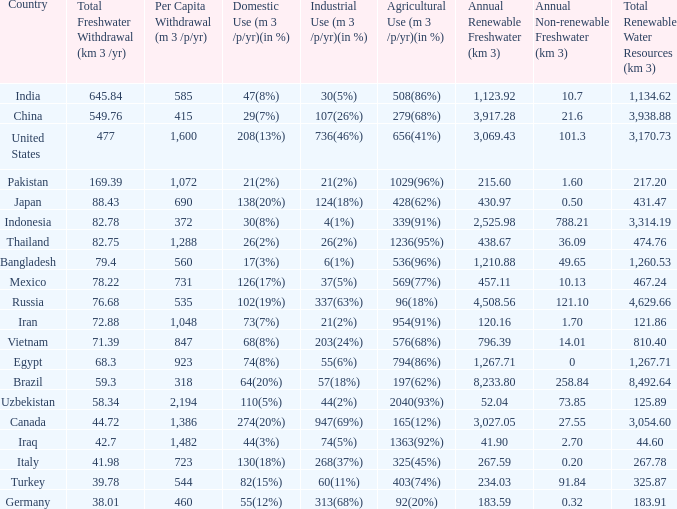Would you be able to parse every entry in this table? {'header': ['Country', 'Total Freshwater Withdrawal (km 3 /yr)', 'Per Capita Withdrawal (m 3 /p/yr)', 'Domestic Use (m 3 /p/yr)(in %)', 'Industrial Use (m 3 /p/yr)(in %)', 'Agricultural Use (m 3 /p/yr)(in %)', 'Annual Renewable Freshwater (km 3)', 'Annual Non-renewable Freshwater (km 3)', 'Total Renewable Water Resources (km 3)'], 'rows': [['India', '645.84', '585', '47(8%)', '30(5%)', '508(86%)', '1,123.92', '10.7', '1,134.62'], ['China', '549.76', '415', '29(7%)', '107(26%)', '279(68%)', '3,917.28', '21.6', '3,938.88'], ['United States', '477', '1,600', '208(13%)', '736(46%)', '656(41%)', '3,069.43', '101.3', '3,170.73'], ['Pakistan', '169.39', '1,072', '21(2%)', '21(2%)', '1029(96%)', '215.60', '1.60', '217.20'], ['Japan', '88.43', '690', '138(20%)', '124(18%)', '428(62%)', '430.97', '0.50', '431.47'], ['Indonesia', '82.78', '372', '30(8%)', '4(1%)', '339(91%)', '2,525.98', '788.21', '3,314.19'], ['Thailand', '82.75', '1,288', '26(2%)', '26(2%)', '1236(95%)', '438.67', '36.09', '474.76'], ['Bangladesh', '79.4', '560', '17(3%)', '6(1%)', '536(96%)', '1,210.88', '49.65', '1,260.53'], ['Mexico', '78.22', '731', '126(17%)', '37(5%)', '569(77%)', '457.11', '10.13', '467.24'], ['Russia', '76.68', '535', '102(19%)', '337(63%)', '96(18%)', '4,508.56', '121.10', '4,629.66'], ['Iran', '72.88', '1,048', '73(7%)', '21(2%)', '954(91%)', '120.16', '1.70', '121.86'], ['Vietnam', '71.39', '847', '68(8%)', '203(24%)', '576(68%)', '796.39', '14.01', '810.40'], ['Egypt', '68.3', '923', '74(8%)', '55(6%)', '794(86%)', '1,267.71', '0', '1,267.71'], ['Brazil', '59.3', '318', '64(20%)', '57(18%)', '197(62%)', '8,233.80', '258.84', '8,492.64'], ['Uzbekistan', '58.34', '2,194', '110(5%)', '44(2%)', '2040(93%)', '52.04', '73.85', '125.89'], ['Canada', '44.72', '1,386', '274(20%)', '947(69%)', '165(12%)', '3,027.05', '27.55', '3,054.60'], ['Iraq', '42.7', '1,482', '44(3%)', '74(5%)', '1363(92%)', '41.90', '2.70', '44.60'], ['Italy', '41.98', '723', '130(18%)', '268(37%)', '325(45%)', '267.59', '0.20', '267.78'], ['Turkey', '39.78', '544', '82(15%)', '60(11%)', '403(74%)', '234.03', '91.84', '325.87'], ['Germany', '38.01', '460', '55(12%)', '313(68%)', '92(20%)', '183.59', '0.32', '183.91']]} What is the average Total Freshwater Withdrawal (km 3 /yr), when Industrial Use (m 3 /p/yr)(in %) is 337(63%), and when Per Capita Withdrawal (m 3 /p/yr) is greater than 535? None. 